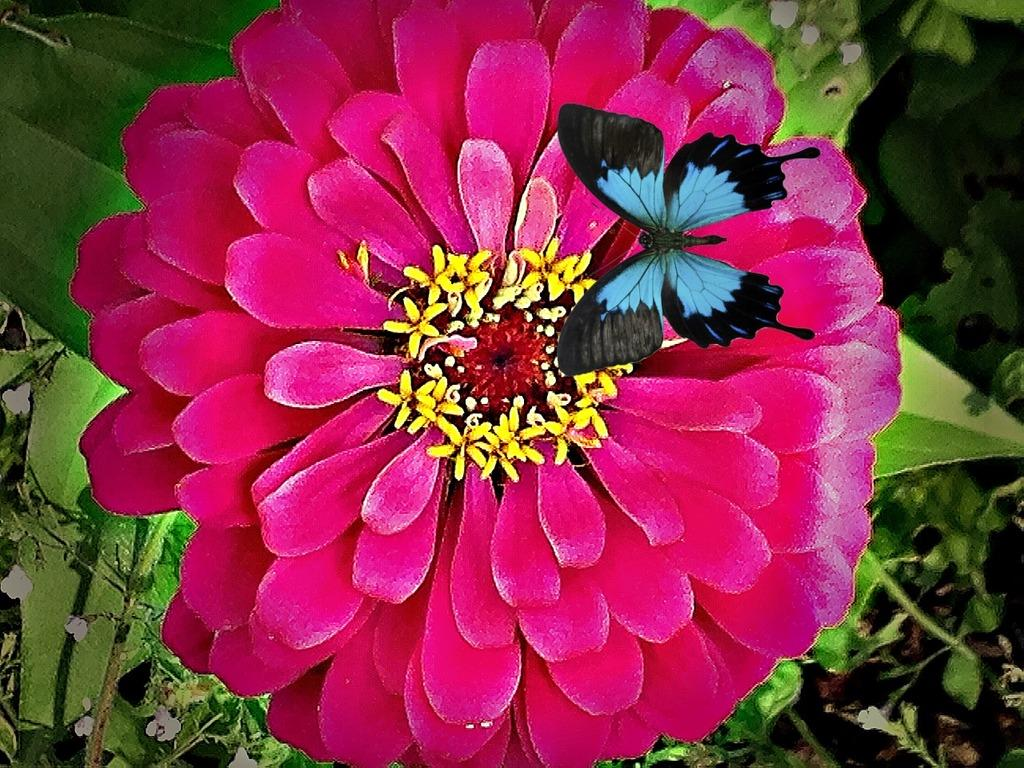What is the main subject in the image? There is a butterfly in the image. What type of flower can be seen in the image? There is a red color flower in the image. How would you describe the background of the image? The background of the image is blurred. How many nuts are visible on the butterfly in the image? There are no nuts present on the butterfly in the image. Can you see any sheep in the wilderness in the image? There is no wilderness or sheep present in the image. 